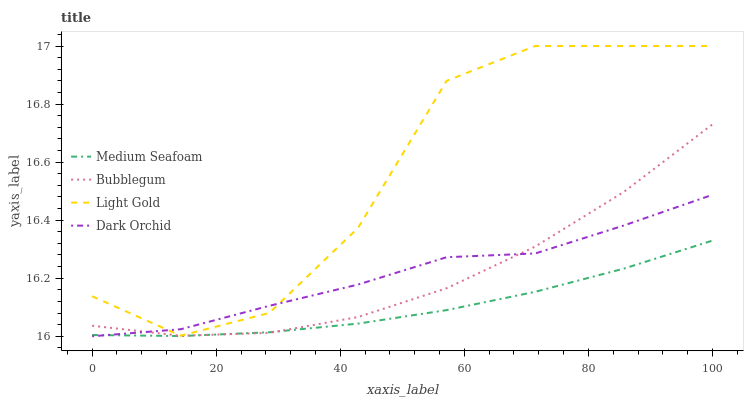Does Medium Seafoam have the minimum area under the curve?
Answer yes or no. Yes. Does Light Gold have the maximum area under the curve?
Answer yes or no. Yes. Does Light Gold have the minimum area under the curve?
Answer yes or no. No. Does Medium Seafoam have the maximum area under the curve?
Answer yes or no. No. Is Medium Seafoam the smoothest?
Answer yes or no. Yes. Is Light Gold the roughest?
Answer yes or no. Yes. Is Light Gold the smoothest?
Answer yes or no. No. Is Medium Seafoam the roughest?
Answer yes or no. No. Does Dark Orchid have the lowest value?
Answer yes or no. Yes. Does Medium Seafoam have the lowest value?
Answer yes or no. No. Does Light Gold have the highest value?
Answer yes or no. Yes. Does Medium Seafoam have the highest value?
Answer yes or no. No. Is Medium Seafoam less than Light Gold?
Answer yes or no. Yes. Is Light Gold greater than Medium Seafoam?
Answer yes or no. Yes. Does Dark Orchid intersect Medium Seafoam?
Answer yes or no. Yes. Is Dark Orchid less than Medium Seafoam?
Answer yes or no. No. Is Dark Orchid greater than Medium Seafoam?
Answer yes or no. No. Does Medium Seafoam intersect Light Gold?
Answer yes or no. No. 